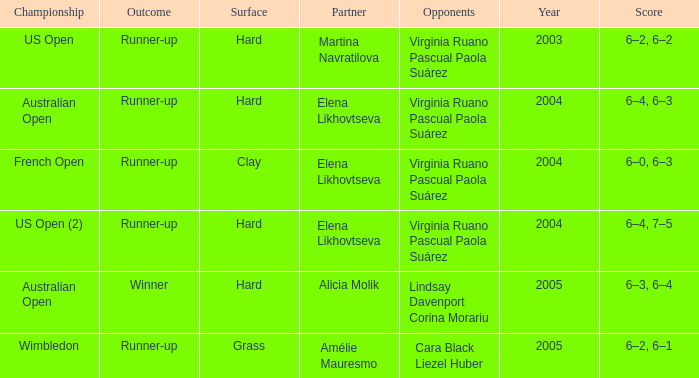When alicia molik is the partner what is the outcome? Winner. 